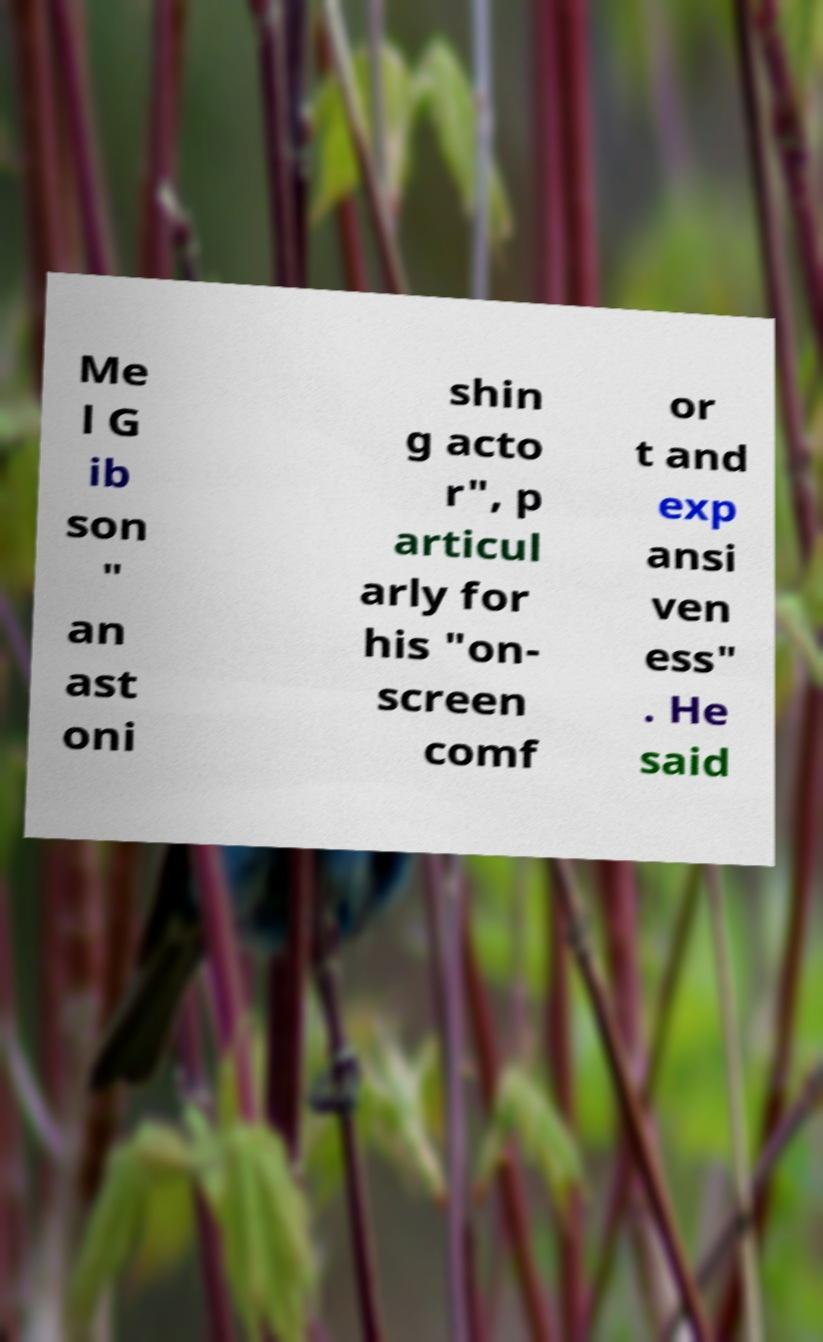What messages or text are displayed in this image? I need them in a readable, typed format. Me l G ib son " an ast oni shin g acto r", p articul arly for his "on- screen comf or t and exp ansi ven ess" . He said 